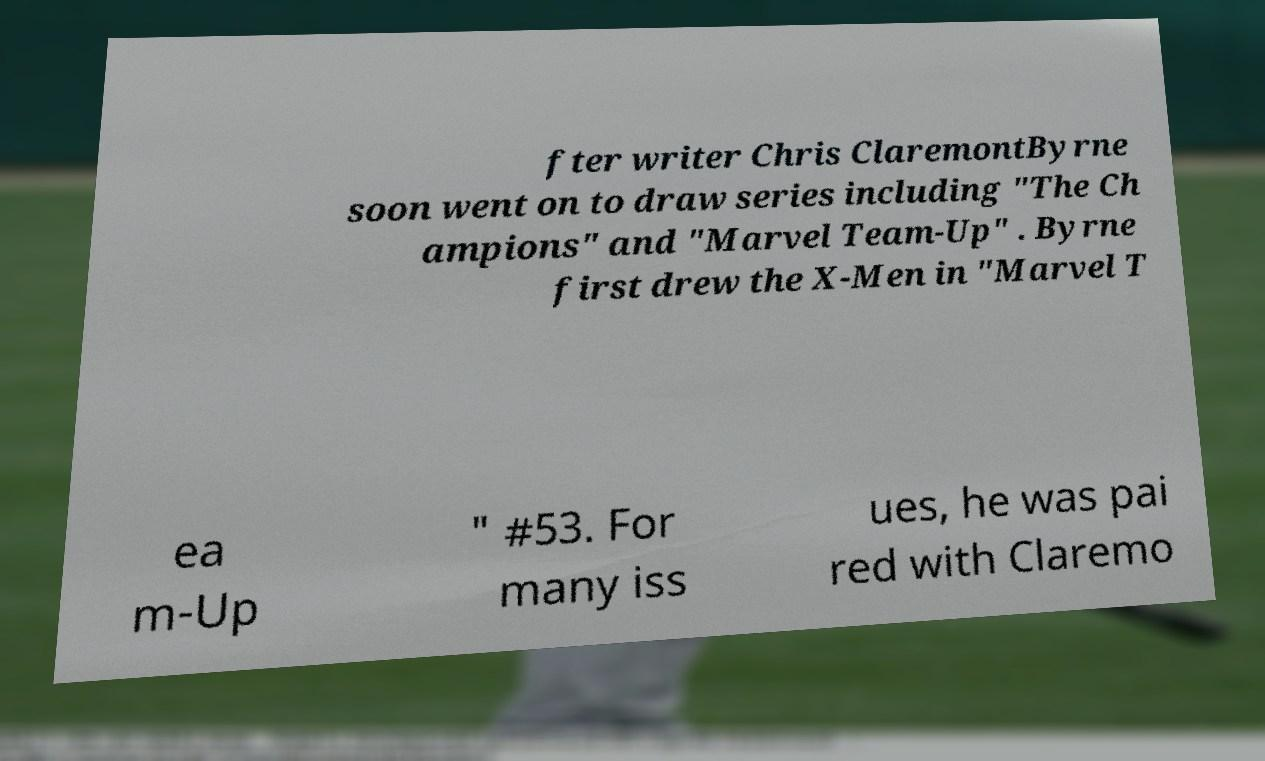Can you read and provide the text displayed in the image?This photo seems to have some interesting text. Can you extract and type it out for me? fter writer Chris ClaremontByrne soon went on to draw series including "The Ch ampions" and "Marvel Team-Up" . Byrne first drew the X-Men in "Marvel T ea m-Up " #53. For many iss ues, he was pai red with Claremo 